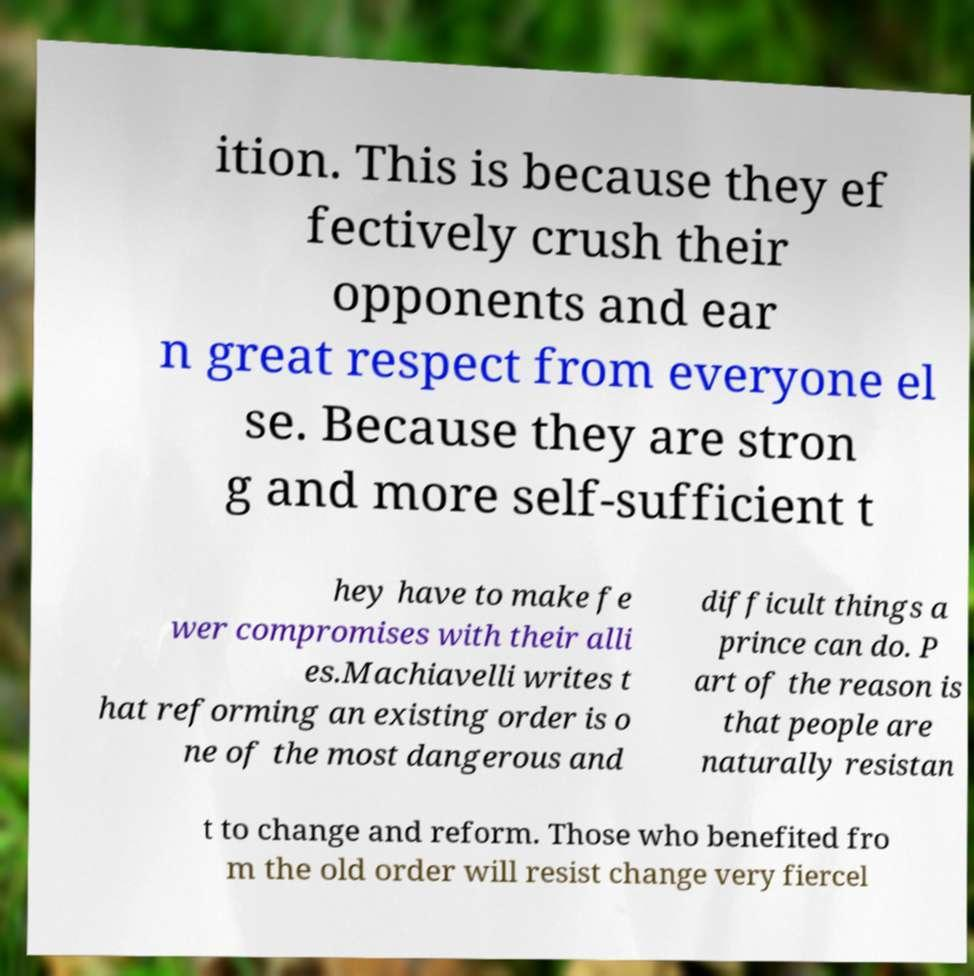Can you read and provide the text displayed in the image?This photo seems to have some interesting text. Can you extract and type it out for me? ition. This is because they ef fectively crush their opponents and ear n great respect from everyone el se. Because they are stron g and more self-sufficient t hey have to make fe wer compromises with their alli es.Machiavelli writes t hat reforming an existing order is o ne of the most dangerous and difficult things a prince can do. P art of the reason is that people are naturally resistan t to change and reform. Those who benefited fro m the old order will resist change very fiercel 